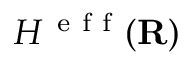<formula> <loc_0><loc_0><loc_500><loc_500>H ^ { e f f } ( { R } )</formula> 